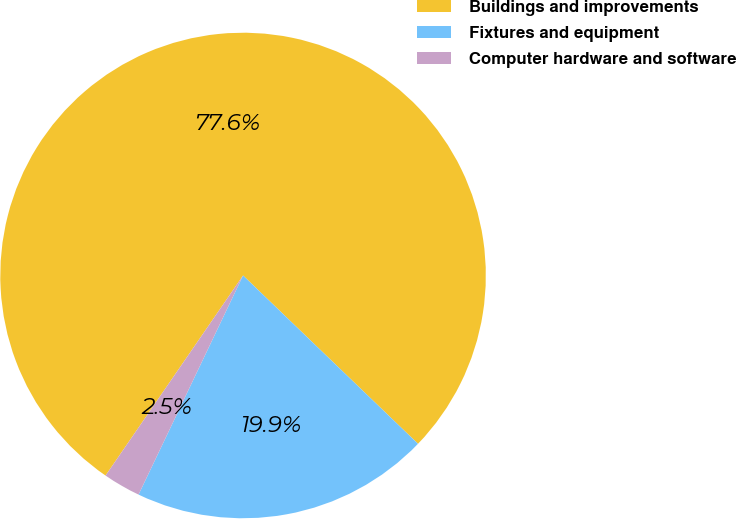Convert chart. <chart><loc_0><loc_0><loc_500><loc_500><pie_chart><fcel>Buildings and improvements<fcel>Fixtures and equipment<fcel>Computer hardware and software<nl><fcel>77.61%<fcel>19.89%<fcel>2.5%<nl></chart> 